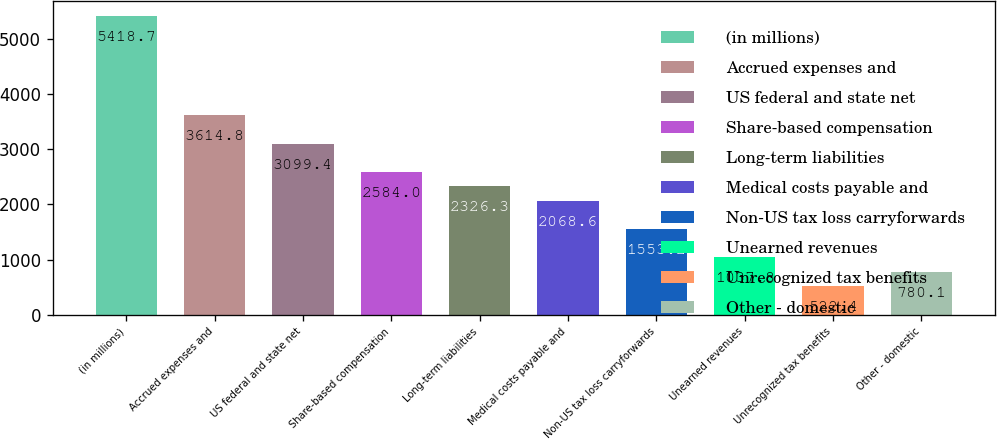<chart> <loc_0><loc_0><loc_500><loc_500><bar_chart><fcel>(in millions)<fcel>Accrued expenses and<fcel>US federal and state net<fcel>Share-based compensation<fcel>Long-term liabilities<fcel>Medical costs payable and<fcel>Non-US tax loss carryforwards<fcel>Unearned revenues<fcel>Unrecognized tax benefits<fcel>Other - domestic<nl><fcel>5418.7<fcel>3614.8<fcel>3099.4<fcel>2584<fcel>2326.3<fcel>2068.6<fcel>1553.2<fcel>1037.8<fcel>522.4<fcel>780.1<nl></chart> 